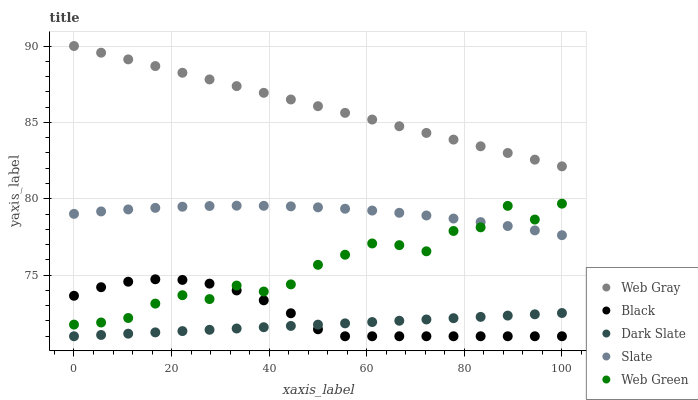Does Dark Slate have the minimum area under the curve?
Answer yes or no. Yes. Does Web Gray have the maximum area under the curve?
Answer yes or no. Yes. Does Slate have the minimum area under the curve?
Answer yes or no. No. Does Slate have the maximum area under the curve?
Answer yes or no. No. Is Web Gray the smoothest?
Answer yes or no. Yes. Is Web Green the roughest?
Answer yes or no. Yes. Is Slate the smoothest?
Answer yes or no. No. Is Slate the roughest?
Answer yes or no. No. Does Dark Slate have the lowest value?
Answer yes or no. Yes. Does Slate have the lowest value?
Answer yes or no. No. Does Web Gray have the highest value?
Answer yes or no. Yes. Does Slate have the highest value?
Answer yes or no. No. Is Dark Slate less than Web Gray?
Answer yes or no. Yes. Is Web Gray greater than Black?
Answer yes or no. Yes. Does Web Green intersect Black?
Answer yes or no. Yes. Is Web Green less than Black?
Answer yes or no. No. Is Web Green greater than Black?
Answer yes or no. No. Does Dark Slate intersect Web Gray?
Answer yes or no. No. 